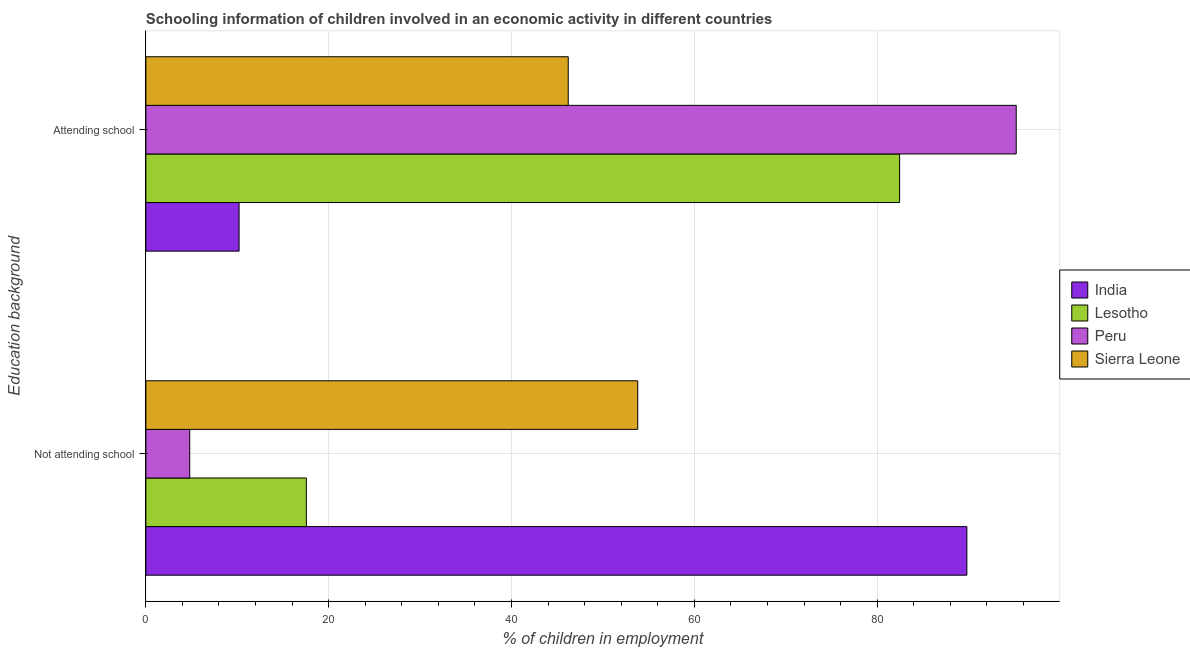Are the number of bars per tick equal to the number of legend labels?
Offer a very short reply. Yes. How many bars are there on the 2nd tick from the top?
Your response must be concise. 4. How many bars are there on the 2nd tick from the bottom?
Your response must be concise. 4. What is the label of the 1st group of bars from the top?
Your answer should be very brief. Attending school. What is the percentage of employed children who are attending school in India?
Offer a terse response. 10.2. Across all countries, what is the maximum percentage of employed children who are attending school?
Your answer should be compact. 95.2. In which country was the percentage of employed children who are not attending school maximum?
Make the answer very short. India. In which country was the percentage of employed children who are not attending school minimum?
Provide a succinct answer. Peru. What is the total percentage of employed children who are attending school in the graph?
Provide a succinct answer. 234.04. What is the difference between the percentage of employed children who are not attending school in Lesotho and that in Peru?
Ensure brevity in your answer.  12.76. What is the difference between the percentage of employed children who are attending school in Sierra Leone and the percentage of employed children who are not attending school in Lesotho?
Give a very brief answer. 28.64. What is the average percentage of employed children who are not attending school per country?
Keep it short and to the point. 41.49. What is the difference between the percentage of employed children who are not attending school and percentage of employed children who are attending school in Lesotho?
Offer a terse response. -64.89. In how many countries, is the percentage of employed children who are not attending school greater than 24 %?
Offer a terse response. 2. What is the ratio of the percentage of employed children who are not attending school in Sierra Leone to that in Lesotho?
Your answer should be compact. 3.06. Is the percentage of employed children who are attending school in Lesotho less than that in India?
Offer a terse response. No. In how many countries, is the percentage of employed children who are attending school greater than the average percentage of employed children who are attending school taken over all countries?
Your response must be concise. 2. What does the 1st bar from the top in Attending school represents?
Offer a very short reply. Sierra Leone. What does the 4th bar from the bottom in Attending school represents?
Keep it short and to the point. Sierra Leone. Are all the bars in the graph horizontal?
Give a very brief answer. Yes. How many countries are there in the graph?
Keep it short and to the point. 4. What is the difference between two consecutive major ticks on the X-axis?
Ensure brevity in your answer.  20. Are the values on the major ticks of X-axis written in scientific E-notation?
Keep it short and to the point. No. Does the graph contain any zero values?
Provide a short and direct response. No. Does the graph contain grids?
Your answer should be very brief. Yes. Where does the legend appear in the graph?
Keep it short and to the point. Center right. How many legend labels are there?
Your answer should be compact. 4. What is the title of the graph?
Give a very brief answer. Schooling information of children involved in an economic activity in different countries. Does "Sint Maarten (Dutch part)" appear as one of the legend labels in the graph?
Your answer should be very brief. No. What is the label or title of the X-axis?
Your answer should be compact. % of children in employment. What is the label or title of the Y-axis?
Offer a very short reply. Education background. What is the % of children in employment in India in Not attending school?
Your response must be concise. 89.8. What is the % of children in employment of Lesotho in Not attending school?
Keep it short and to the point. 17.56. What is the % of children in employment in Peru in Not attending school?
Offer a terse response. 4.8. What is the % of children in employment in Sierra Leone in Not attending school?
Provide a succinct answer. 53.8. What is the % of children in employment of India in Attending school?
Ensure brevity in your answer.  10.2. What is the % of children in employment in Lesotho in Attending school?
Your answer should be compact. 82.44. What is the % of children in employment in Peru in Attending school?
Offer a terse response. 95.2. What is the % of children in employment in Sierra Leone in Attending school?
Give a very brief answer. 46.2. Across all Education background, what is the maximum % of children in employment of India?
Offer a terse response. 89.8. Across all Education background, what is the maximum % of children in employment in Lesotho?
Give a very brief answer. 82.44. Across all Education background, what is the maximum % of children in employment in Peru?
Your answer should be very brief. 95.2. Across all Education background, what is the maximum % of children in employment of Sierra Leone?
Keep it short and to the point. 53.8. Across all Education background, what is the minimum % of children in employment of India?
Make the answer very short. 10.2. Across all Education background, what is the minimum % of children in employment of Lesotho?
Keep it short and to the point. 17.56. Across all Education background, what is the minimum % of children in employment of Peru?
Provide a succinct answer. 4.8. Across all Education background, what is the minimum % of children in employment in Sierra Leone?
Provide a short and direct response. 46.2. What is the total % of children in employment in India in the graph?
Give a very brief answer. 100. What is the total % of children in employment in Lesotho in the graph?
Your response must be concise. 100. What is the total % of children in employment of Peru in the graph?
Ensure brevity in your answer.  100. What is the total % of children in employment of Sierra Leone in the graph?
Give a very brief answer. 100. What is the difference between the % of children in employment in India in Not attending school and that in Attending school?
Ensure brevity in your answer.  79.6. What is the difference between the % of children in employment in Lesotho in Not attending school and that in Attending school?
Your answer should be very brief. -64.89. What is the difference between the % of children in employment in Peru in Not attending school and that in Attending school?
Offer a very short reply. -90.4. What is the difference between the % of children in employment of Sierra Leone in Not attending school and that in Attending school?
Your answer should be very brief. 7.6. What is the difference between the % of children in employment in India in Not attending school and the % of children in employment in Lesotho in Attending school?
Provide a succinct answer. 7.36. What is the difference between the % of children in employment in India in Not attending school and the % of children in employment in Sierra Leone in Attending school?
Your response must be concise. 43.6. What is the difference between the % of children in employment of Lesotho in Not attending school and the % of children in employment of Peru in Attending school?
Your response must be concise. -77.64. What is the difference between the % of children in employment in Lesotho in Not attending school and the % of children in employment in Sierra Leone in Attending school?
Your answer should be very brief. -28.64. What is the difference between the % of children in employment of Peru in Not attending school and the % of children in employment of Sierra Leone in Attending school?
Provide a short and direct response. -41.4. What is the average % of children in employment of Lesotho per Education background?
Give a very brief answer. 50. What is the difference between the % of children in employment of India and % of children in employment of Lesotho in Not attending school?
Ensure brevity in your answer.  72.24. What is the difference between the % of children in employment in Lesotho and % of children in employment in Peru in Not attending school?
Ensure brevity in your answer.  12.76. What is the difference between the % of children in employment of Lesotho and % of children in employment of Sierra Leone in Not attending school?
Make the answer very short. -36.24. What is the difference between the % of children in employment in Peru and % of children in employment in Sierra Leone in Not attending school?
Keep it short and to the point. -49. What is the difference between the % of children in employment of India and % of children in employment of Lesotho in Attending school?
Ensure brevity in your answer.  -72.24. What is the difference between the % of children in employment in India and % of children in employment in Peru in Attending school?
Your answer should be compact. -85. What is the difference between the % of children in employment in India and % of children in employment in Sierra Leone in Attending school?
Offer a very short reply. -36. What is the difference between the % of children in employment in Lesotho and % of children in employment in Peru in Attending school?
Your answer should be compact. -12.76. What is the difference between the % of children in employment of Lesotho and % of children in employment of Sierra Leone in Attending school?
Make the answer very short. 36.24. What is the ratio of the % of children in employment in India in Not attending school to that in Attending school?
Provide a short and direct response. 8.8. What is the ratio of the % of children in employment in Lesotho in Not attending school to that in Attending school?
Offer a very short reply. 0.21. What is the ratio of the % of children in employment in Peru in Not attending school to that in Attending school?
Ensure brevity in your answer.  0.05. What is the ratio of the % of children in employment of Sierra Leone in Not attending school to that in Attending school?
Make the answer very short. 1.16. What is the difference between the highest and the second highest % of children in employment in India?
Offer a very short reply. 79.6. What is the difference between the highest and the second highest % of children in employment in Lesotho?
Your answer should be very brief. 64.89. What is the difference between the highest and the second highest % of children in employment in Peru?
Keep it short and to the point. 90.4. What is the difference between the highest and the lowest % of children in employment of India?
Give a very brief answer. 79.6. What is the difference between the highest and the lowest % of children in employment of Lesotho?
Keep it short and to the point. 64.89. What is the difference between the highest and the lowest % of children in employment in Peru?
Provide a succinct answer. 90.4. 